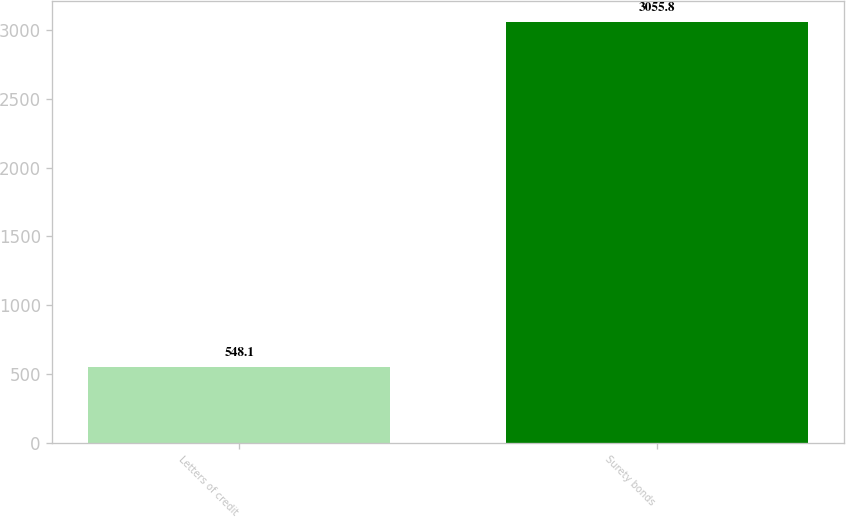Convert chart to OTSL. <chart><loc_0><loc_0><loc_500><loc_500><bar_chart><fcel>Letters of credit<fcel>Surety bonds<nl><fcel>548.1<fcel>3055.8<nl></chart> 